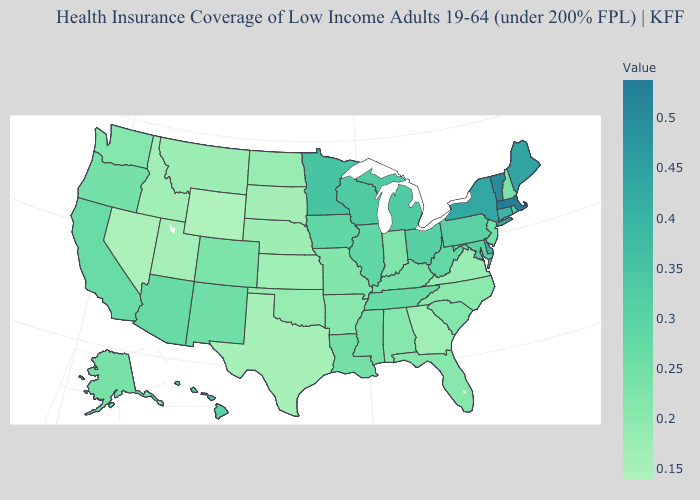Does the map have missing data?
Give a very brief answer. No. Does Minnesota have the lowest value in the MidWest?
Quick response, please. No. Does Nevada have the lowest value in the USA?
Short answer required. No. Does Texas have a lower value than Washington?
Write a very short answer. Yes. Does Pennsylvania have a lower value than Kansas?
Quick response, please. No. Does South Carolina have the highest value in the South?
Be succinct. No. 